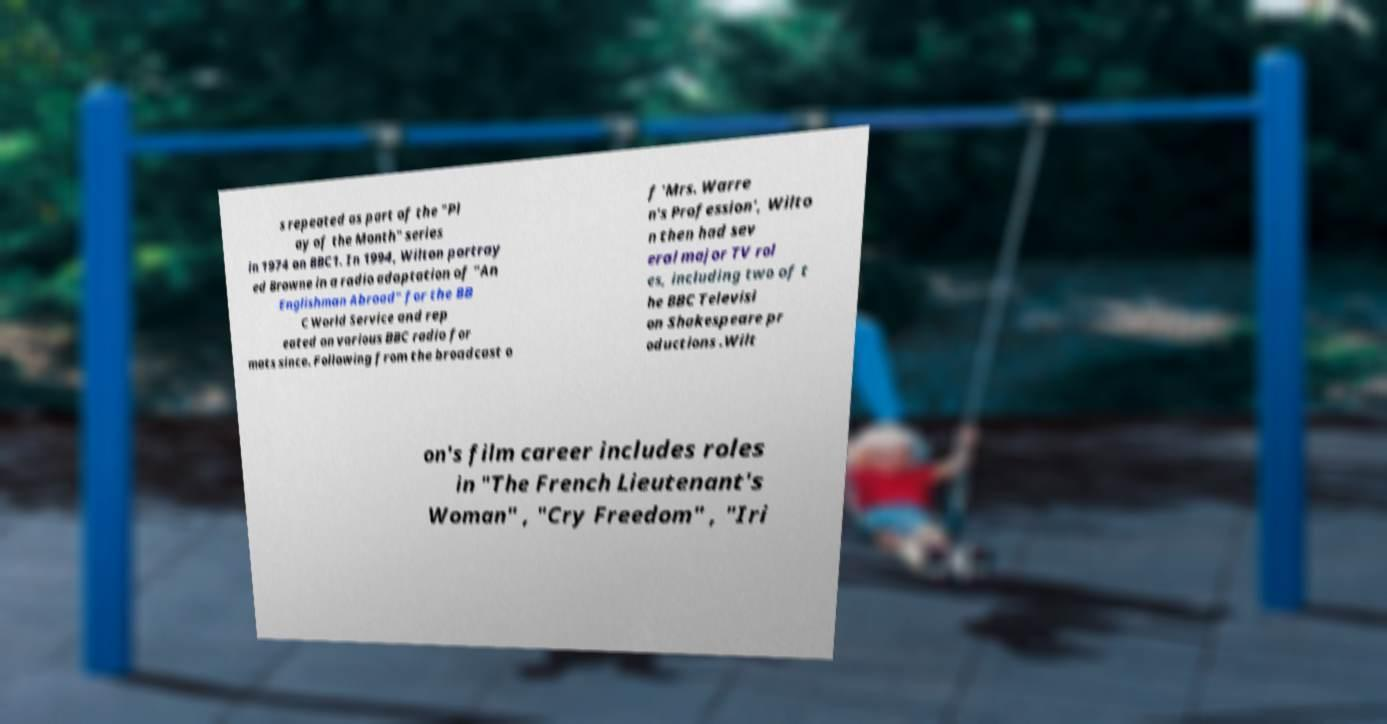Can you read and provide the text displayed in the image?This photo seems to have some interesting text. Can you extract and type it out for me? s repeated as part of the "Pl ay of the Month" series in 1974 on BBC1. In 1994, Wilton portray ed Browne in a radio adaptation of "An Englishman Abroad" for the BB C World Service and rep eated on various BBC radio for mats since. Following from the broadcast o f 'Mrs. Warre n's Profession', Wilto n then had sev eral major TV rol es, including two of t he BBC Televisi on Shakespeare pr oductions .Wilt on's film career includes roles in "The French Lieutenant's Woman" , "Cry Freedom" , "Iri 